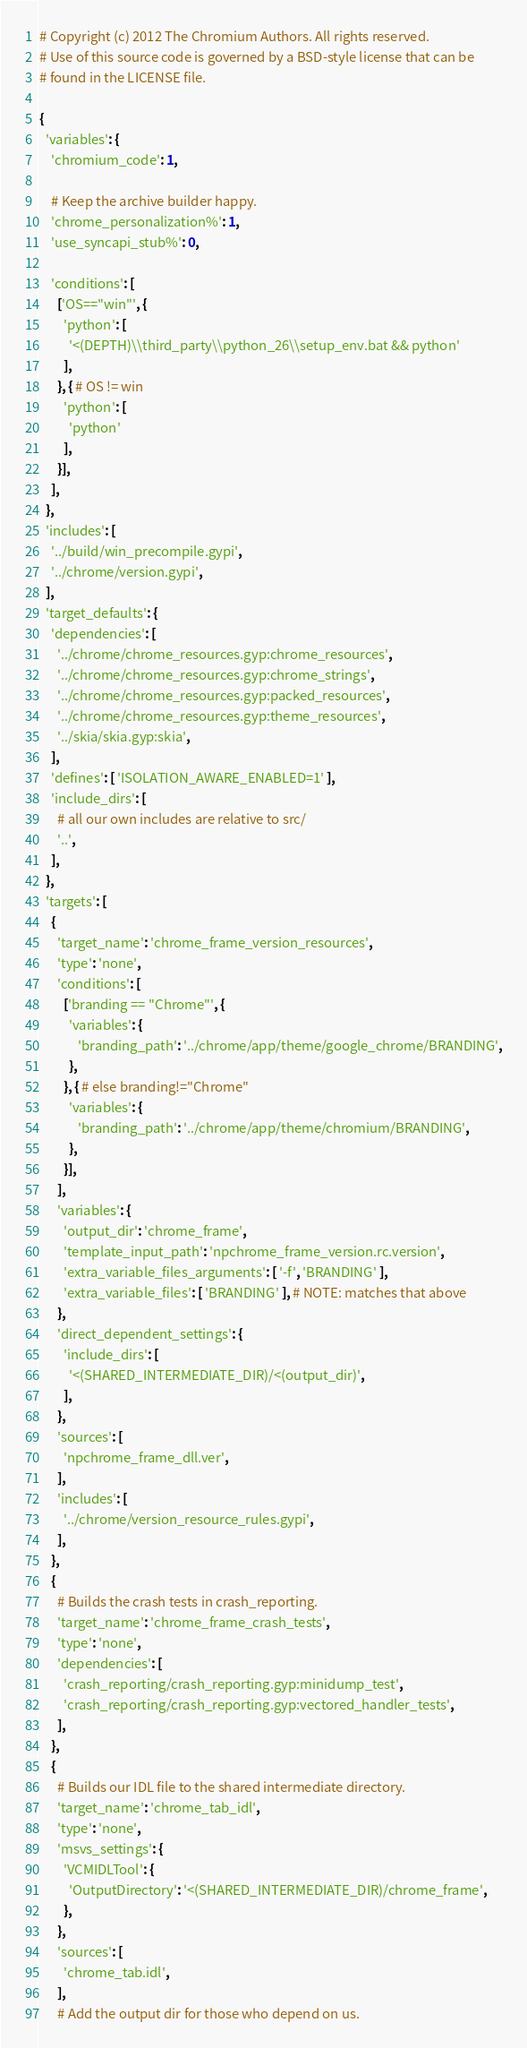<code> <loc_0><loc_0><loc_500><loc_500><_Python_># Copyright (c) 2012 The Chromium Authors. All rights reserved.
# Use of this source code is governed by a BSD-style license that can be
# found in the LICENSE file.

{
  'variables': {
    'chromium_code': 1,

    # Keep the archive builder happy.
    'chrome_personalization%': 1,
    'use_syncapi_stub%': 0,

    'conditions': [
      ['OS=="win"', {
        'python': [
          '<(DEPTH)\\third_party\\python_26\\setup_env.bat && python'
        ],
      }, { # OS != win
        'python': [
          'python'
        ],
      }],
    ],
  },
  'includes': [
    '../build/win_precompile.gypi',
    '../chrome/version.gypi',
  ],
  'target_defaults': {
    'dependencies': [
      '../chrome/chrome_resources.gyp:chrome_resources',
      '../chrome/chrome_resources.gyp:chrome_strings',
      '../chrome/chrome_resources.gyp:packed_resources',
      '../chrome/chrome_resources.gyp:theme_resources',
      '../skia/skia.gyp:skia',
    ],
    'defines': [ 'ISOLATION_AWARE_ENABLED=1' ],
    'include_dirs': [
      # all our own includes are relative to src/
      '..',
    ],
  },
  'targets': [
    {
      'target_name': 'chrome_frame_version_resources',
      'type': 'none',
      'conditions': [
        ['branding == "Chrome"', {
          'variables': {
             'branding_path': '../chrome/app/theme/google_chrome/BRANDING',
          },
        }, { # else branding!="Chrome"
          'variables': {
             'branding_path': '../chrome/app/theme/chromium/BRANDING',
          },
        }],
      ],
      'variables': {
        'output_dir': 'chrome_frame',
        'template_input_path': 'npchrome_frame_version.rc.version',
        'extra_variable_files_arguments': [ '-f', 'BRANDING' ],
        'extra_variable_files': [ 'BRANDING' ], # NOTE: matches that above
      },
      'direct_dependent_settings': {
        'include_dirs': [
          '<(SHARED_INTERMEDIATE_DIR)/<(output_dir)',
        ],
      },
      'sources': [
        'npchrome_frame_dll.ver',
      ],
      'includes': [
        '../chrome/version_resource_rules.gypi',
      ],
    },
    {
      # Builds the crash tests in crash_reporting.
      'target_name': 'chrome_frame_crash_tests',
      'type': 'none',
      'dependencies': [
        'crash_reporting/crash_reporting.gyp:minidump_test',
        'crash_reporting/crash_reporting.gyp:vectored_handler_tests',
      ],
    },
    {
      # Builds our IDL file to the shared intermediate directory.
      'target_name': 'chrome_tab_idl',
      'type': 'none',
      'msvs_settings': {
        'VCMIDLTool': {
          'OutputDirectory': '<(SHARED_INTERMEDIATE_DIR)/chrome_frame',
        },
      },
      'sources': [
        'chrome_tab.idl',
      ],
      # Add the output dir for those who depend on us.</code> 